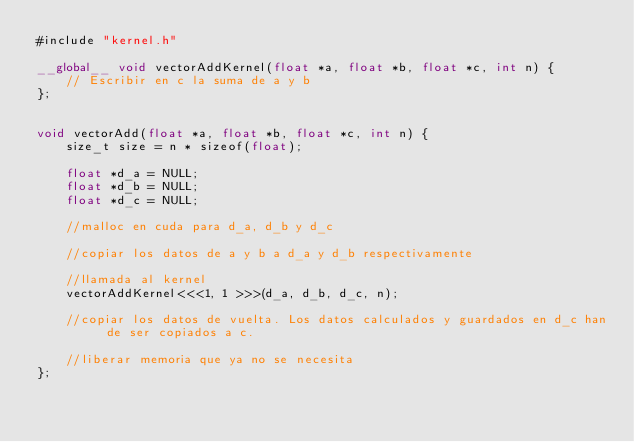Convert code to text. <code><loc_0><loc_0><loc_500><loc_500><_Cuda_>#include "kernel.h"

__global__ void vectorAddKernel(float *a, float *b, float *c, int n) {
	// Escribir en c la suma de a y b
};


void vectorAdd(float *a, float *b, float *c, int n) {
	size_t size = n * sizeof(float);

	float *d_a = NULL;
	float *d_b = NULL;
	float *d_c = NULL;

	//malloc en cuda para d_a, d_b y d_c

	//copiar los datos de a y b a d_a y d_b respectivamente

	//llamada al kernel
	vectorAddKernel<<<1, 1 >>>(d_a, d_b, d_c, n);

	//copiar los datos de vuelta. Los datos calculados y guardados en d_c han de ser copiados a c.

	//liberar memoria que ya no se necesita
};
</code> 